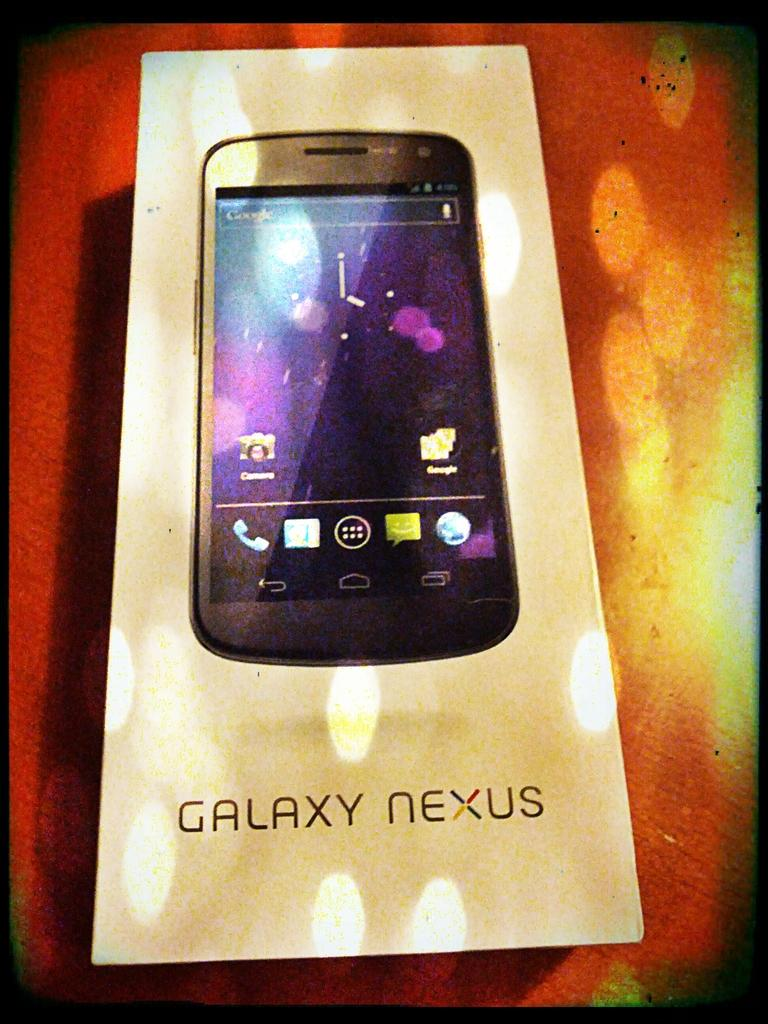<image>
Summarize the visual content of the image. A Galaxy Nexus device is sitting on a wooden surface. 